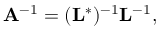Convert formula to latex. <formula><loc_0><loc_0><loc_500><loc_500>A ^ { - 1 } = ( L ^ { * } ) ^ { - 1 } L ^ { - 1 } ,</formula> 